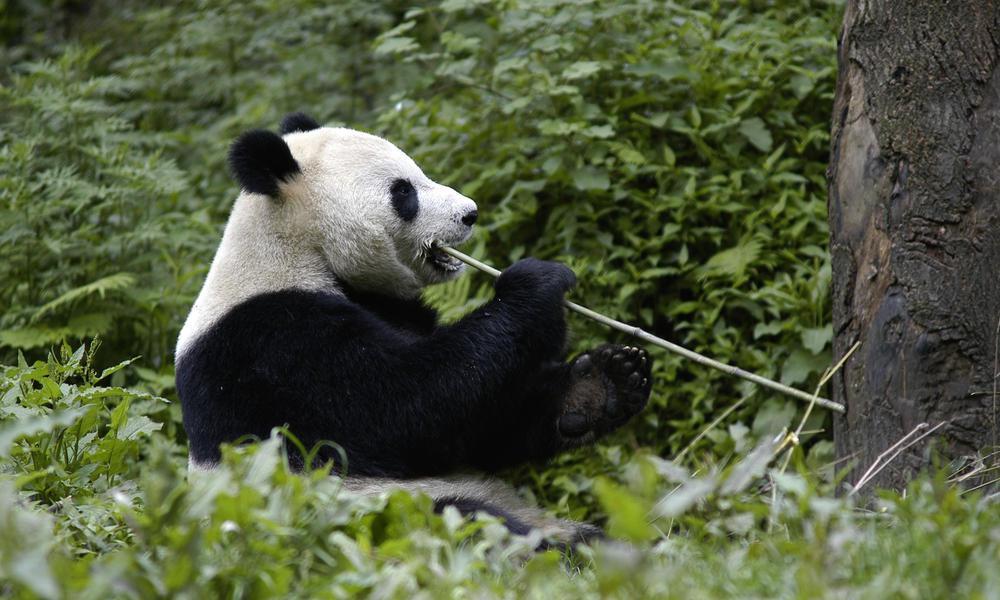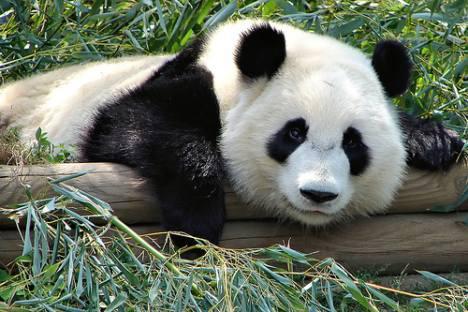The first image is the image on the left, the second image is the image on the right. Given the left and right images, does the statement "One image shows a pair of pandas side-by-side in similar poses, and the other features just one panda." hold true? Answer yes or no. No. The first image is the image on the left, the second image is the image on the right. Given the left and right images, does the statement "One giant panda is resting its chin on a log." hold true? Answer yes or no. Yes. 